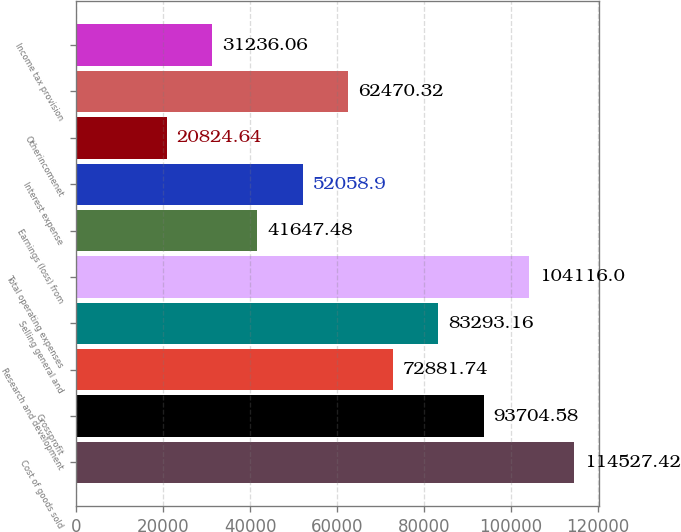<chart> <loc_0><loc_0><loc_500><loc_500><bar_chart><fcel>Cost of goods sold<fcel>Grossprofit<fcel>Research and development<fcel>Selling general and<fcel>Total operating expenses<fcel>Earnings (loss) from<fcel>Interest expense<fcel>Otherincomenet<fcel>Unnamed: 8<fcel>Income tax provision<nl><fcel>114527<fcel>93704.6<fcel>72881.7<fcel>83293.2<fcel>104116<fcel>41647.5<fcel>52058.9<fcel>20824.6<fcel>62470.3<fcel>31236.1<nl></chart> 